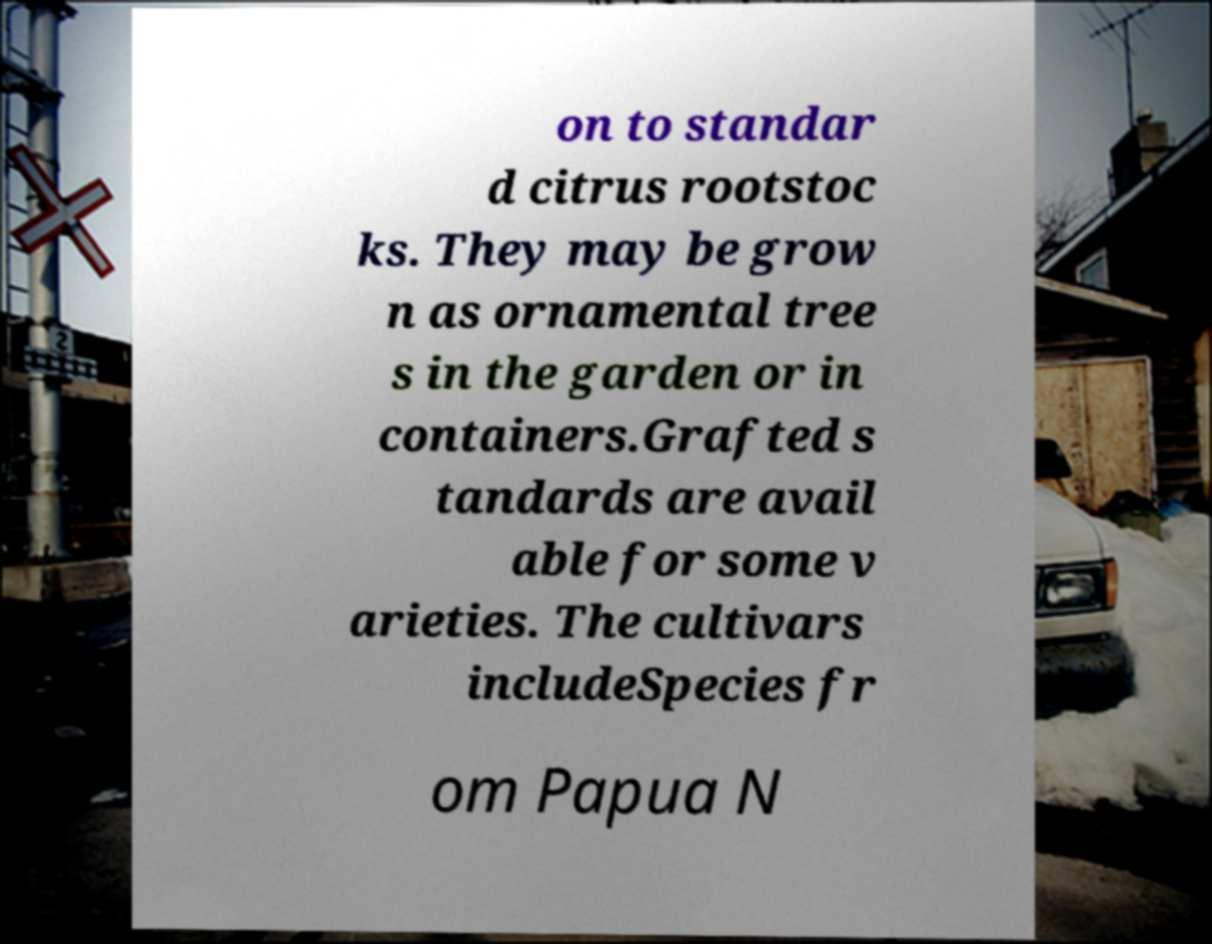Could you assist in decoding the text presented in this image and type it out clearly? on to standar d citrus rootstoc ks. They may be grow n as ornamental tree s in the garden or in containers.Grafted s tandards are avail able for some v arieties. The cultivars includeSpecies fr om Papua N 